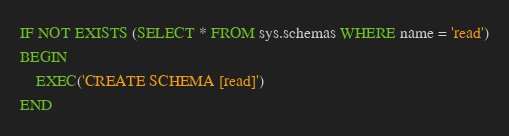<code> <loc_0><loc_0><loc_500><loc_500><_SQL_>IF NOT EXISTS (SELECT * FROM sys.schemas WHERE name = 'read')
BEGIN
	EXEC('CREATE SCHEMA [read]')
END</code> 